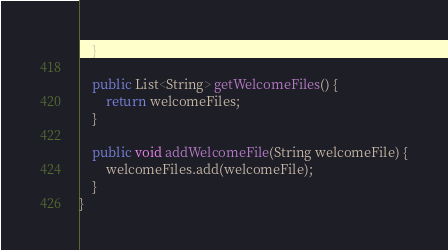<code> <loc_0><loc_0><loc_500><loc_500><_Java_>    }

    public List<String> getWelcomeFiles() {
        return welcomeFiles;
    }

    public void addWelcomeFile(String welcomeFile) {
        welcomeFiles.add(welcomeFile);
    }
}
</code> 